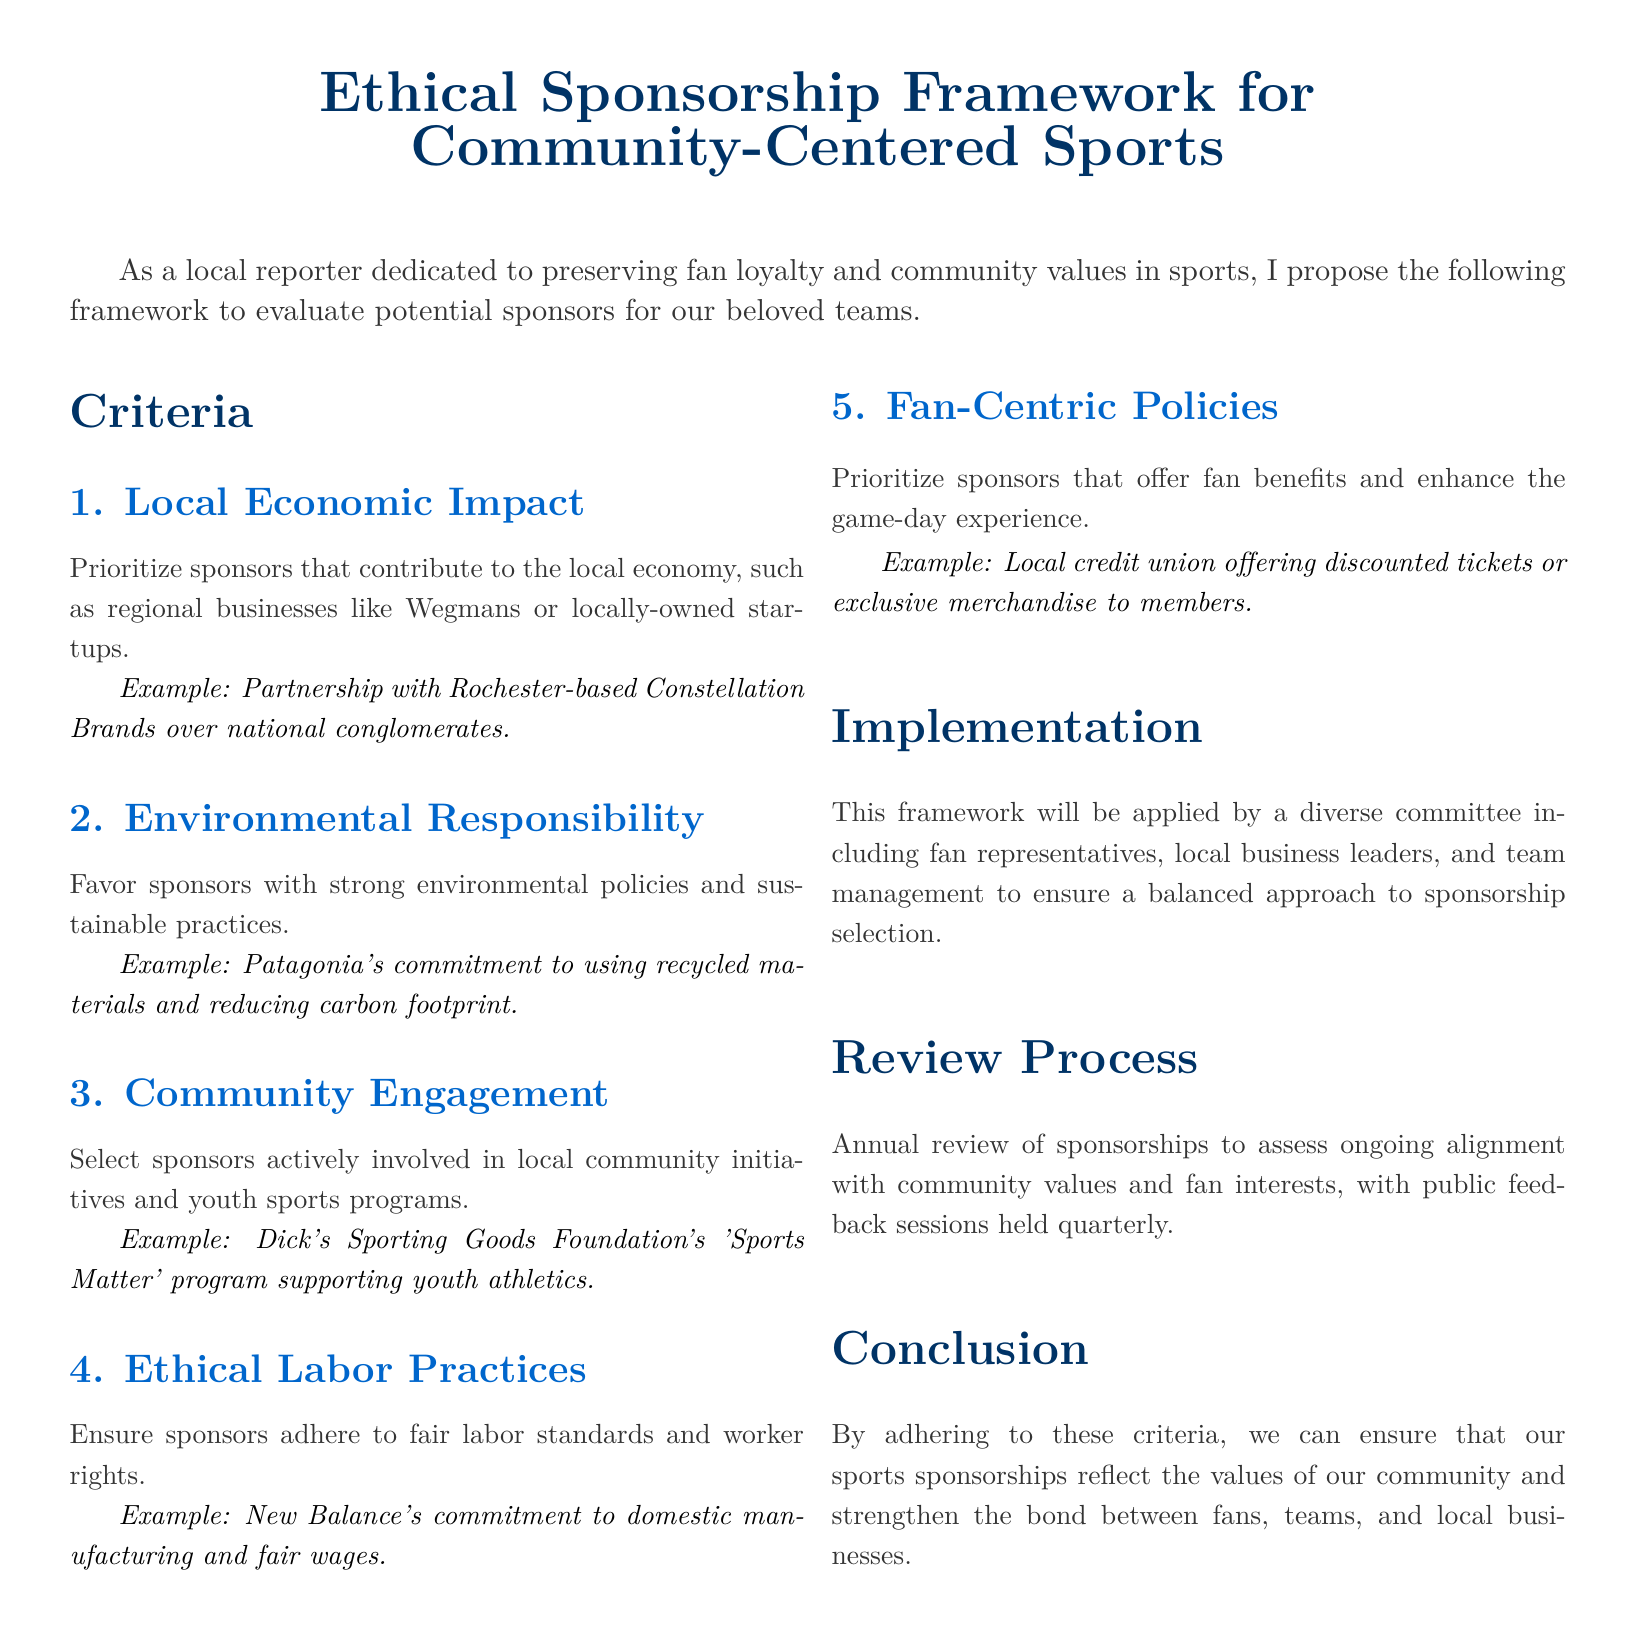What is the title of the document? The title of the document is provided at the beginning of the document, stating the focus on ethical sponsorships that center on community values in sports.
Answer: Ethical Sponsorship Framework for Community-Centered Sports What is the first criterion for evaluating sponsors? The first criterion is mentioned specifically as Local Economic Impact, indicating its priority in the evaluation process.
Answer: Local Economic Impact Which company is an example of a preferred local sponsor? The document includes a specific example of a regional business that embodies the local economic impact criteria.
Answer: Constellation Brands What is the focus of the third criterion? The third criterion is explicitly centered on how sponsors interact and contribute to local communities.
Answer: Community Engagement How often will sponsorships be reviewed? The document clearly states the frequency of the review process to ensure ongoing alignment with community values.
Answer: Annually What is one of the examples provided for Environmental Responsibility? The document offers a specific instance of a company that practices environmental responsibility as part of its sponsorship suitability.
Answer: Patagonia What does the implementation process involve? The implementation process includes community stakeholders to establish a balanced approach for sponsor selection, as highlighted in the document.
Answer: Diverse committee What type of feedback sessions are mentioned? The document outlines the method for public participation, specifically regarding the feedback opportunities for community members.
Answer: Quarterly feedback sessions What is the main goal outlined in the conclusion? The document states the overarching objective of adhering to the framework and its impact on the community and fan relationship.
Answer: Strengthen the bond between fans, teams, and local businesses 